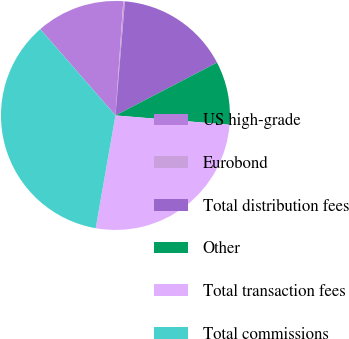<chart> <loc_0><loc_0><loc_500><loc_500><pie_chart><fcel>US high-grade<fcel>Eurobond<fcel>Total distribution fees<fcel>Other<fcel>Total transaction fees<fcel>Total commissions<nl><fcel>12.49%<fcel>0.23%<fcel>16.05%<fcel>8.93%<fcel>26.47%<fcel>35.83%<nl></chart> 